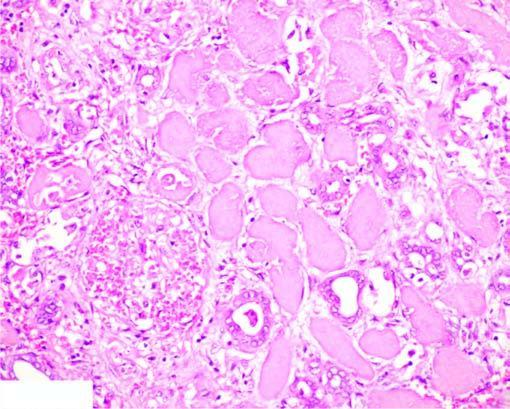does the show cells with intensely eosinophilic cytoplasm of tubular cells?
Answer the question using a single word or phrase. No 